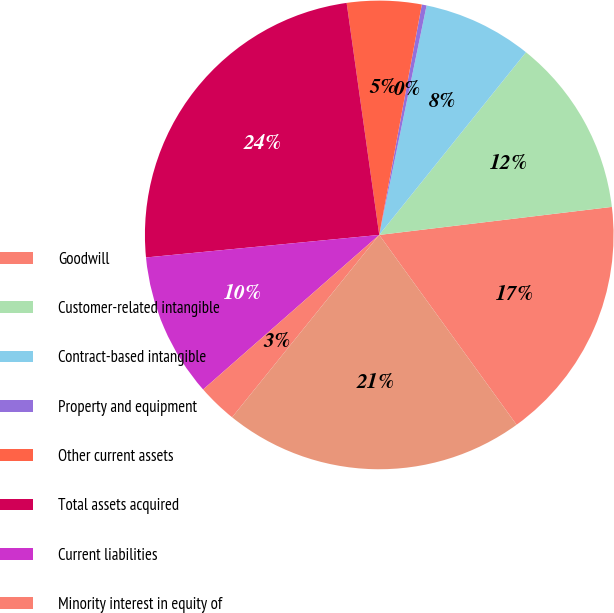<chart> <loc_0><loc_0><loc_500><loc_500><pie_chart><fcel>Goodwill<fcel>Customer-related intangible<fcel>Contract-based intangible<fcel>Property and equipment<fcel>Other current assets<fcel>Total assets acquired<fcel>Current liabilities<fcel>Minority interest in equity of<fcel>Net assets acquired<nl><fcel>16.94%<fcel>12.32%<fcel>7.53%<fcel>0.33%<fcel>5.13%<fcel>24.31%<fcel>9.93%<fcel>2.73%<fcel>20.77%<nl></chart> 